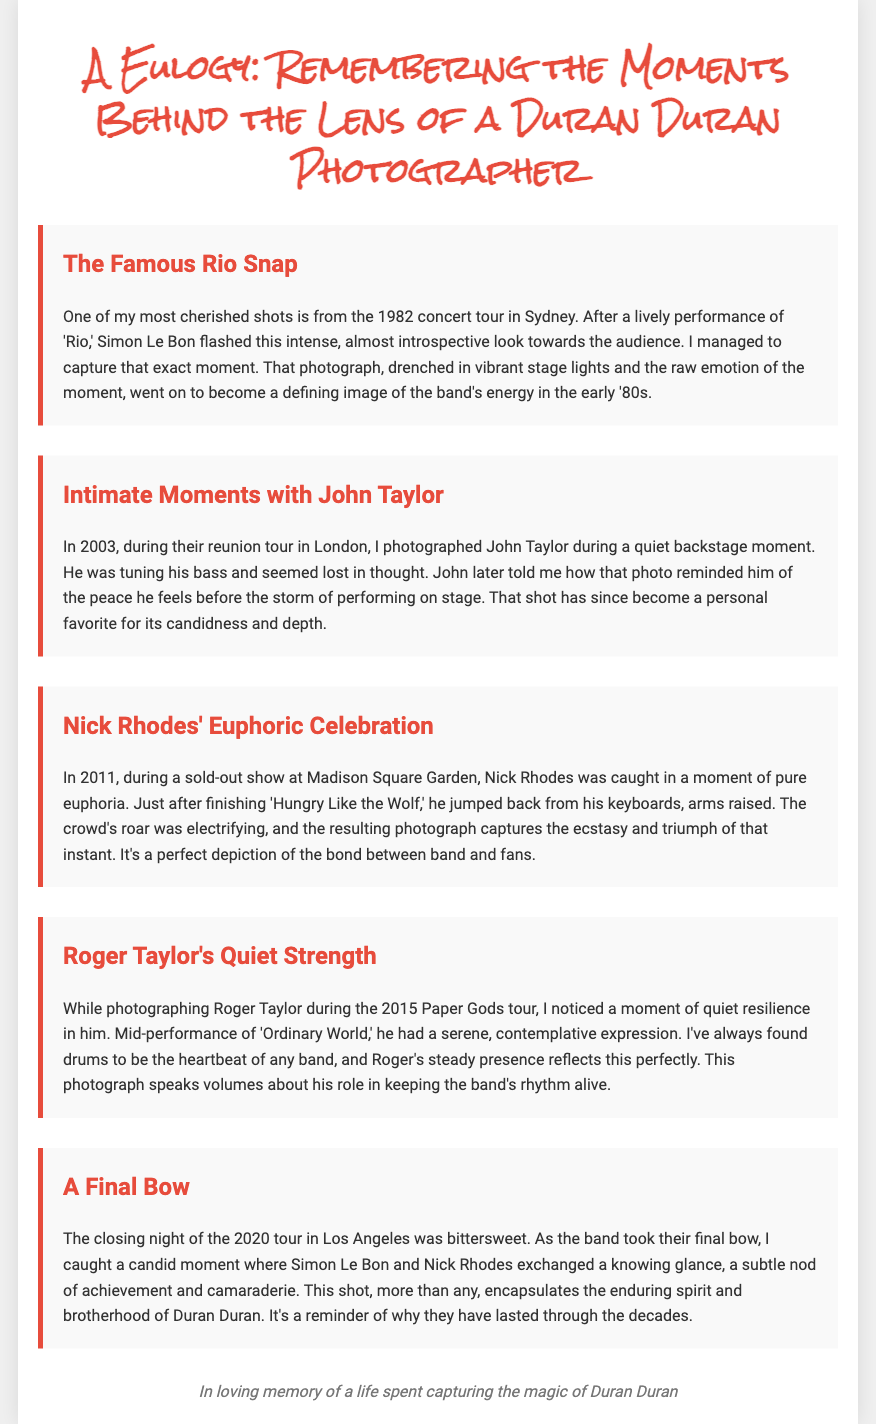What is the title of the document? The title is prominently displayed at the top of the document, indicating the main subject of the eulogy.
Answer: A Eulogy: Remembering the Moments Behind the Lens of a Duran Duran Photographer In which year was the famous Rio snap taken? The specific year is mentioned in the recounting of the anecdote about the photograph captured during the concert tour.
Answer: 1982 What city hosted the concert where the famous Rio snap was taken? The city is provided in the context of the specific anecdote about the memorable shot.
Answer: Sydney During which tour was the photograph of John Taylor taken? This detail is specified in the anecdote describing the context of the photograph of John Taylor.
Answer: 2003 reunion tour What song was being performed when Nick Rhodes had his euphoric moment? The specific song is mentioned within the anecdote recounting Nick Rhodes' expression during the performance.
Answer: Hungry Like the Wolf What is the title of the song that Roger Taylor performed when he exhibited quiet strength? The title of the song is included within the narrative of Roger Taylor's moment on stage.
Answer: Ordinary World What did Simon Le Bon and Nick Rhodes exchange during the final bow? The specific action taken by Simon and Nick is detailed in the context of the closing night of the 2020 tour.
Answer: A knowing glance How does the document reflect on Duran Duran's longevity? The context provided suggests a deeper meaning behind the captured moments, emphasizing the band's enduring spirit and camaraderie as expressed in the final anecdote.
Answer: Enduring spirit and brotherhood What is the overall mood conveyed in the eulogy's anecdotes? The anecdotes reflect an emotional resonance that celebrates significant moments captured through photography, depicting various emotional states of the band.
Answer: Emotional resonance 